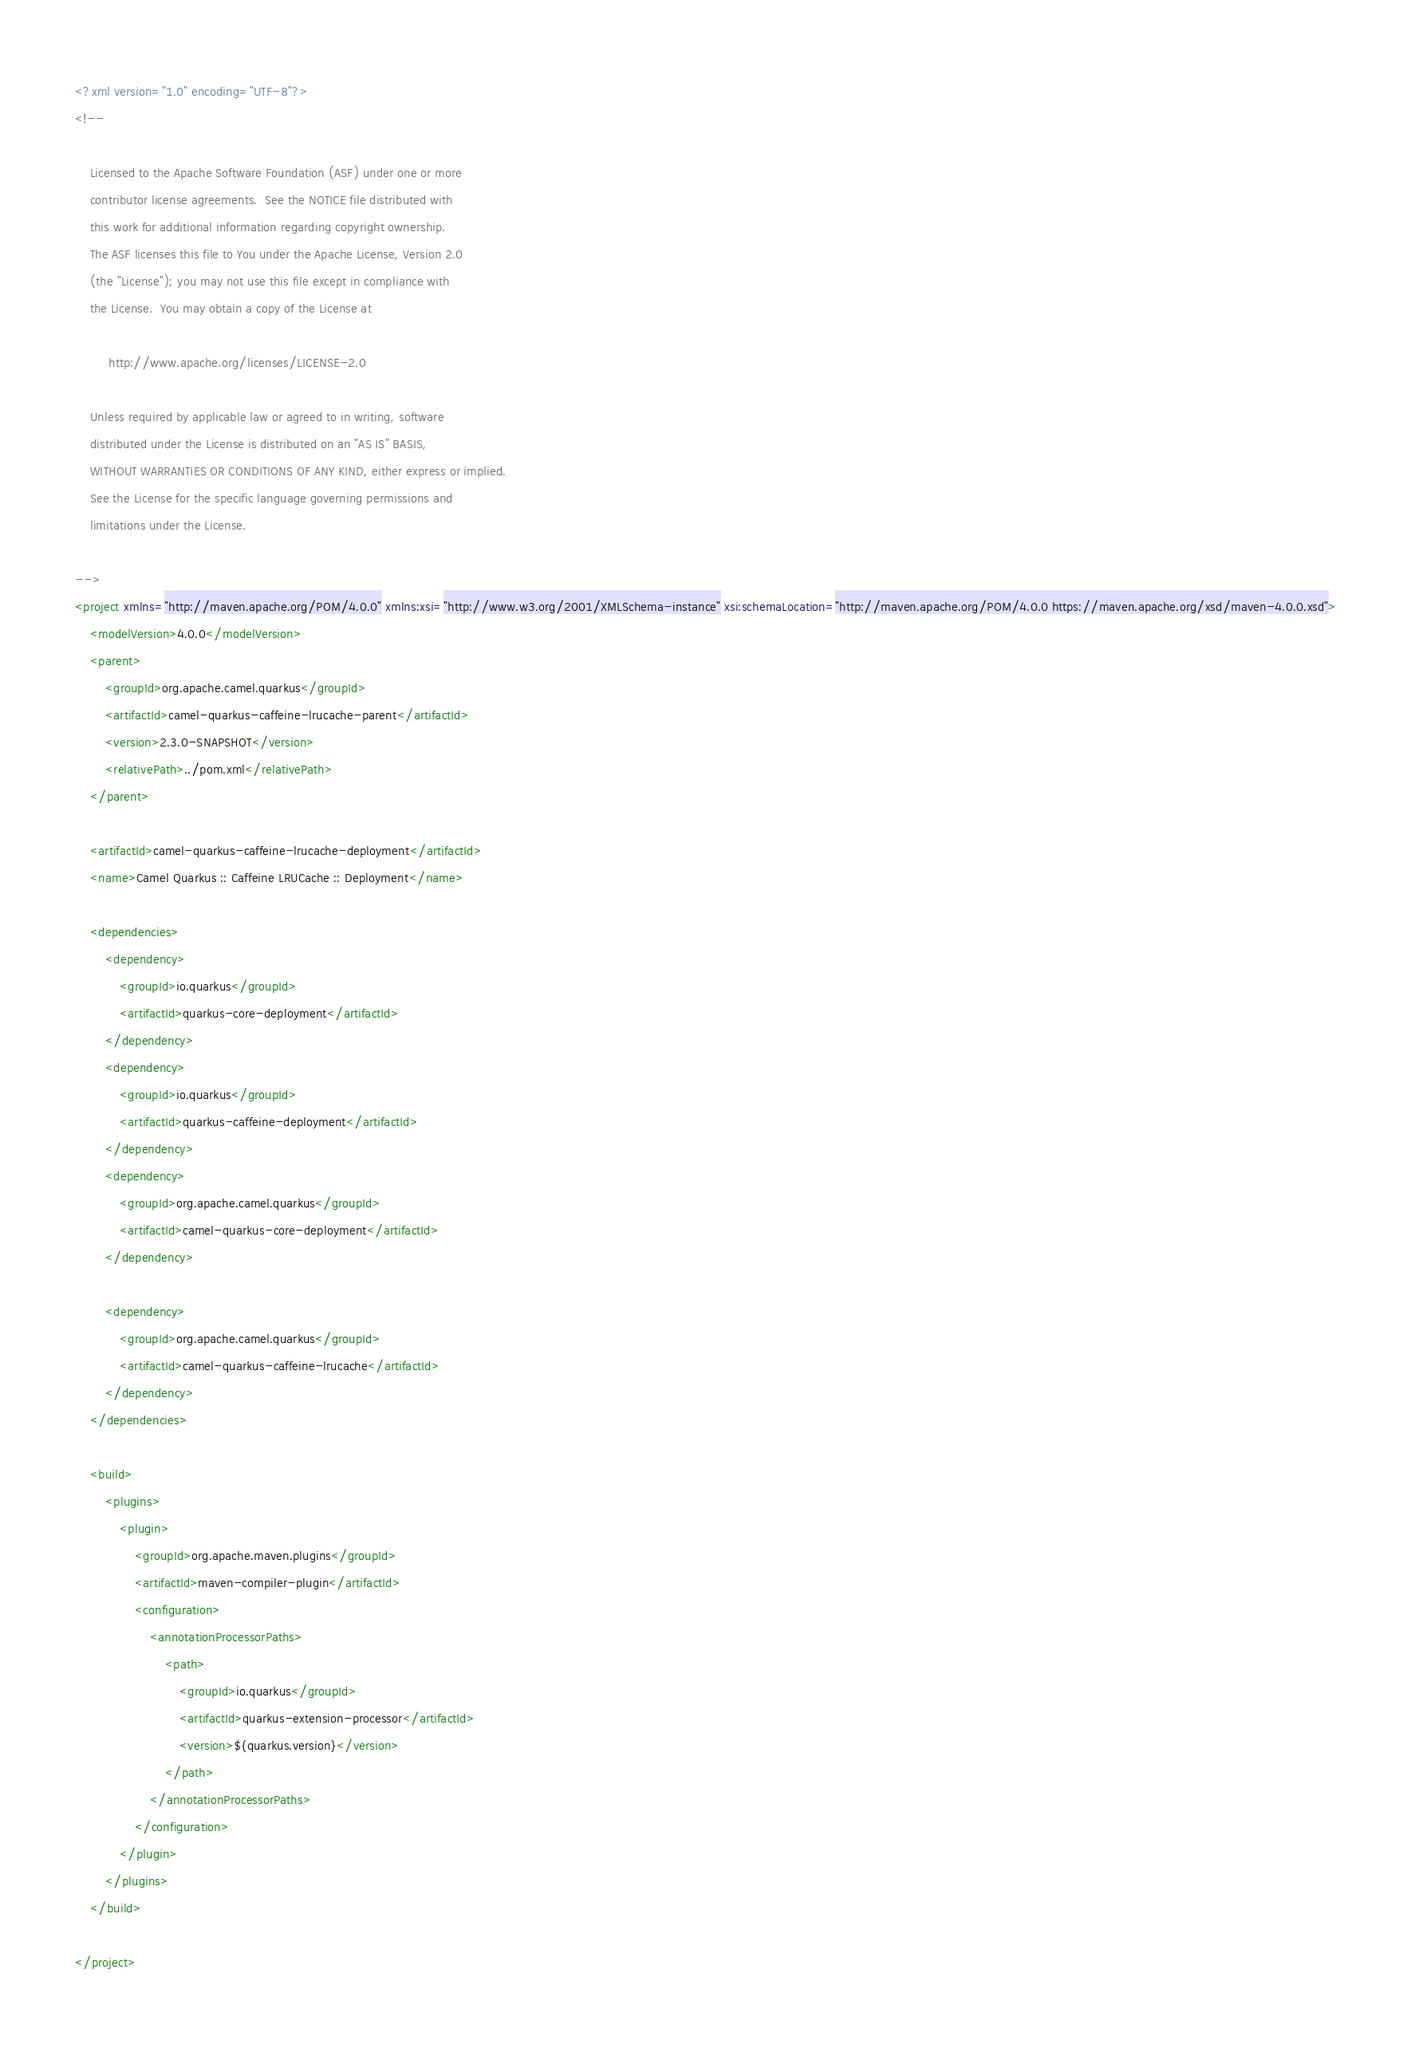Convert code to text. <code><loc_0><loc_0><loc_500><loc_500><_XML_><?xml version="1.0" encoding="UTF-8"?>
<!--

    Licensed to the Apache Software Foundation (ASF) under one or more
    contributor license agreements.  See the NOTICE file distributed with
    this work for additional information regarding copyright ownership.
    The ASF licenses this file to You under the Apache License, Version 2.0
    (the "License"); you may not use this file except in compliance with
    the License.  You may obtain a copy of the License at

         http://www.apache.org/licenses/LICENSE-2.0

    Unless required by applicable law or agreed to in writing, software
    distributed under the License is distributed on an "AS IS" BASIS,
    WITHOUT WARRANTIES OR CONDITIONS OF ANY KIND, either express or implied.
    See the License for the specific language governing permissions and
    limitations under the License.

-->
<project xmlns="http://maven.apache.org/POM/4.0.0" xmlns:xsi="http://www.w3.org/2001/XMLSchema-instance" xsi:schemaLocation="http://maven.apache.org/POM/4.0.0 https://maven.apache.org/xsd/maven-4.0.0.xsd">
    <modelVersion>4.0.0</modelVersion>
    <parent>
        <groupId>org.apache.camel.quarkus</groupId>
        <artifactId>camel-quarkus-caffeine-lrucache-parent</artifactId>
        <version>2.3.0-SNAPSHOT</version>
        <relativePath>../pom.xml</relativePath>
    </parent>

    <artifactId>camel-quarkus-caffeine-lrucache-deployment</artifactId>
    <name>Camel Quarkus :: Caffeine LRUCache :: Deployment</name>

    <dependencies>
        <dependency>
            <groupId>io.quarkus</groupId>
            <artifactId>quarkus-core-deployment</artifactId>
        </dependency>
        <dependency>
            <groupId>io.quarkus</groupId>
            <artifactId>quarkus-caffeine-deployment</artifactId>
        </dependency>
        <dependency>
            <groupId>org.apache.camel.quarkus</groupId>
            <artifactId>camel-quarkus-core-deployment</artifactId>
        </dependency>

        <dependency>
            <groupId>org.apache.camel.quarkus</groupId>
            <artifactId>camel-quarkus-caffeine-lrucache</artifactId>
        </dependency>
    </dependencies>

    <build>
        <plugins>
            <plugin>
                <groupId>org.apache.maven.plugins</groupId>
                <artifactId>maven-compiler-plugin</artifactId>
                <configuration>
                    <annotationProcessorPaths>
                        <path>
                            <groupId>io.quarkus</groupId>
                            <artifactId>quarkus-extension-processor</artifactId>
                            <version>${quarkus.version}</version>
                        </path>
                    </annotationProcessorPaths>
                </configuration>
            </plugin>
        </plugins>
    </build>

</project>
</code> 